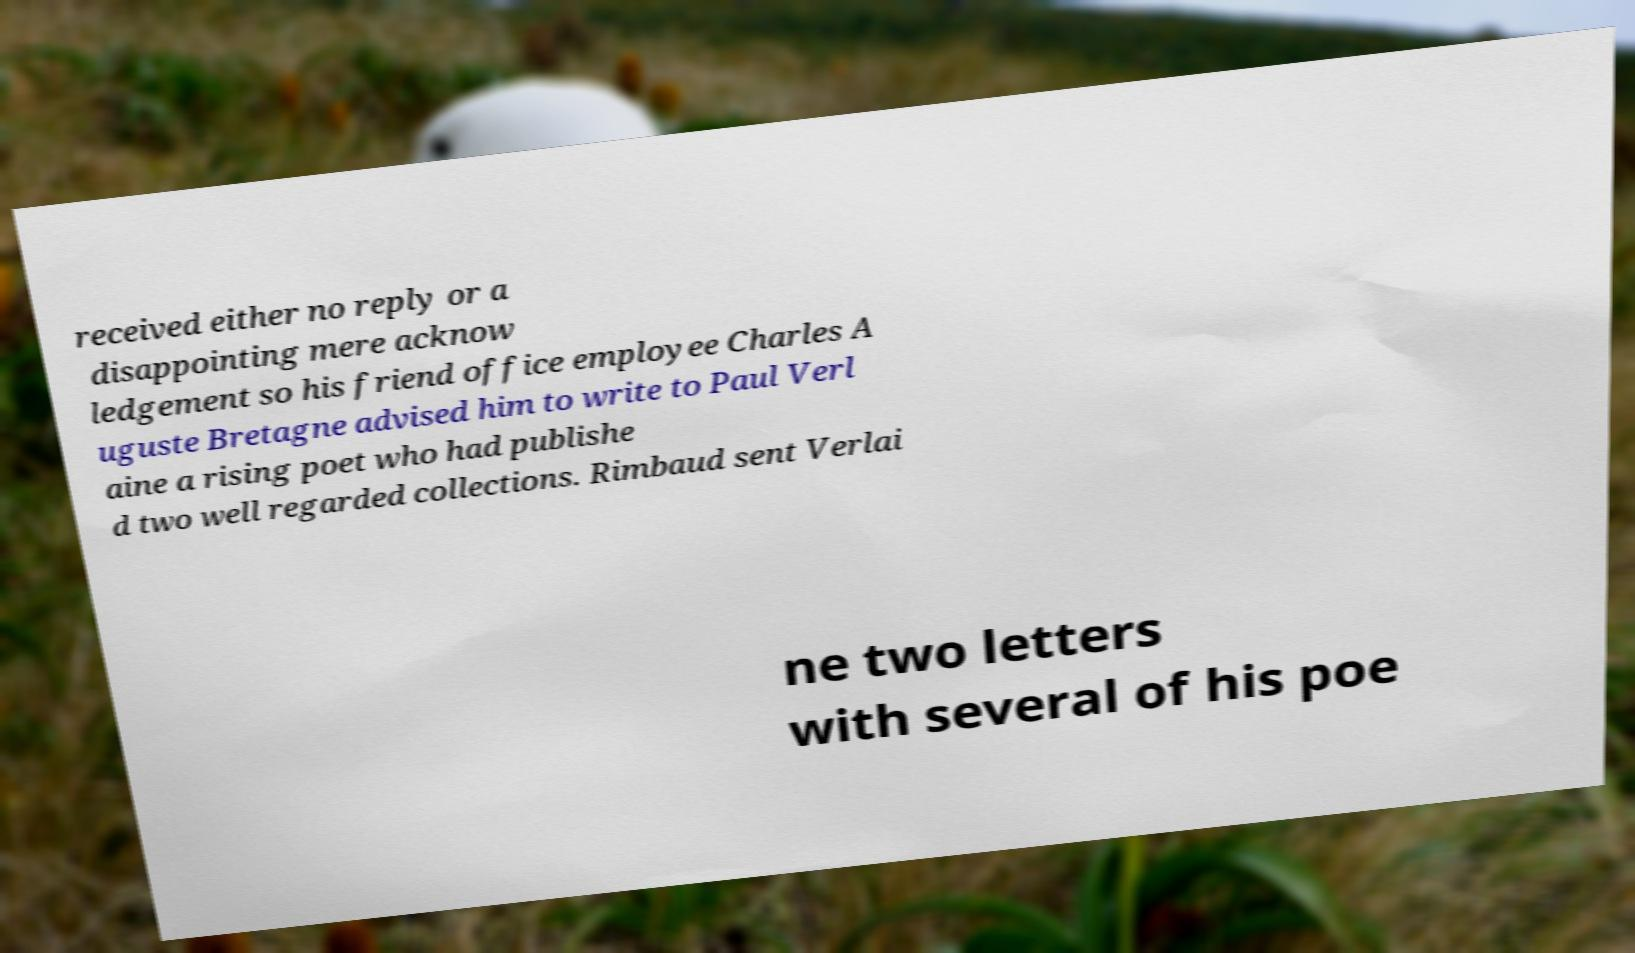Can you read and provide the text displayed in the image?This photo seems to have some interesting text. Can you extract and type it out for me? received either no reply or a disappointing mere acknow ledgement so his friend office employee Charles A uguste Bretagne advised him to write to Paul Verl aine a rising poet who had publishe d two well regarded collections. Rimbaud sent Verlai ne two letters with several of his poe 